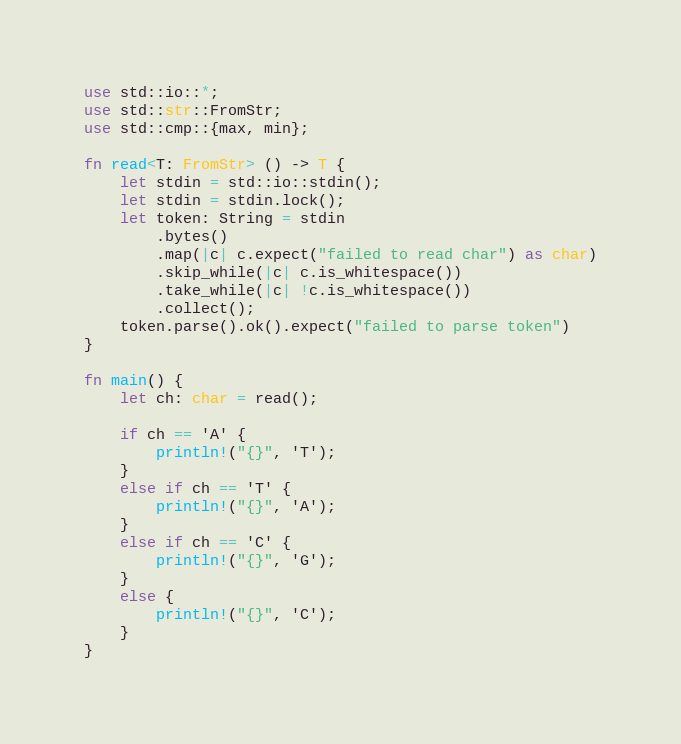<code> <loc_0><loc_0><loc_500><loc_500><_Rust_>use std::io::*;
use std::str::FromStr;
use std::cmp::{max, min};

fn read<T: FromStr> () -> T {
    let stdin = std::io::stdin();
    let stdin = stdin.lock();
    let token: String = stdin
        .bytes()
        .map(|c| c.expect("failed to read char") as char)
        .skip_while(|c| c.is_whitespace())
        .take_while(|c| !c.is_whitespace())
        .collect();
    token.parse().ok().expect("failed to parse token")
}

fn main() {
    let ch: char = read();

    if ch == 'A' {
        println!("{}", 'T');
    }
    else if ch == 'T' {
        println!("{}", 'A');
    }
    else if ch == 'C' {
        println!("{}", 'G');
    }
    else {
        println!("{}", 'C');
    }
}
</code> 